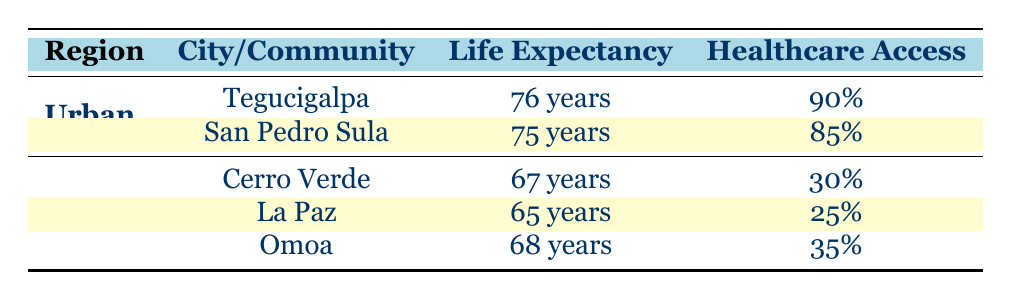What is the average life expectancy in urban areas of Honduras? To find the average life expectancy in urban areas, we take the life expectancy values of the cities listed under "Urban," which are Tegucigalpa (76 years) and San Pedro Sula (75 years). We calculate the average: (76 + 75) / 2 = 75.5 years.
Answer: 75.5 years Which rural community has the lowest life expectancy? The table shows three rural communities: Cerro Verde (67 years), La Paz (65 years), and Omoa (68 years). Among these, La Paz has the lowest life expectancy at 65 years.
Answer: La Paz Is the healthcare access percentage higher in urban areas than in rural areas? In urban areas, the healthcare access rates are 90% for Tegucigalpa and 85% for San Pedro Sula, averaging 87.5%. In rural areas, the access percentages are 30% for Cerro Verde, 25% for La Paz, and 35% for Omoa, averaging 30%. Thus, healthcare access is higher in urban areas.
Answer: Yes What is the difference in average life expectancy between urban and rural areas? The average life expectancy for urban areas is 75.5 years (from question 1), and the average for rural areas is (67 + 65 + 68) / 3 = 66 years. The difference is 75.5 - 66 = 9.5 years.
Answer: 9.5 years Does San Pedro Sula have better healthcare access than La Paz? San Pedro Sula has a healthcare access percentage of 85%, while La Paz has a healthcare access percentage of 25%. Since 85% is greater than 25%, San Pedro Sula does have better healthcare access.
Answer: Yes What is the healthcare access percentage for Omoa? The table directly states that the healthcare access percentage for Omoa is 35%.
Answer: 35% Are there more notable hospitals in Tegucigalpa or healthcare centers in La Paz? Tegucigalpa lists three notable hospitals (Hospital Escuela, Hospital San Felipe, and Centro Medico Valery), while La Paz has two notable health centers (Centro de Salud La Paz and Clínica Rural Santa Rosa). Since three is greater than two, there are more notable hospitals in Tegucigalpa.
Answer: Yes What is the average healthcare access percentage in rural areas? We take the healthcare access percentages for the rural communities: 30% (Cerro Verde), 25% (La Paz), and 35% (Omoa). The average is calculated as (30 + 25 + 35) / 3 = 30%.
Answer: 30% Do both urban cities have a life expectancy greater than the highest life expectancy in rural communities? Urban cities are Tegucigalpa (76 years) and San Pedro Sula (75 years). The highest rural life expectancy is 68 years (Omoa). Both urban life expectancies (76 and 75) are greater than 68 years.
Answer: Yes 